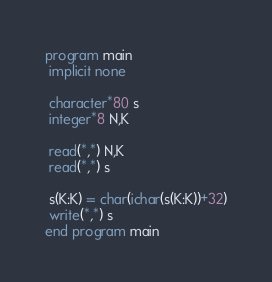<code> <loc_0><loc_0><loc_500><loc_500><_FORTRAN_>program main
 implicit none
 
 character*80 s
 integer*8 N,K
 
 read(*,*) N,K
 read(*,*) s
 
 s(K:K) = char(ichar(s(K:K))+32)
 write(*,*) s
end program main</code> 